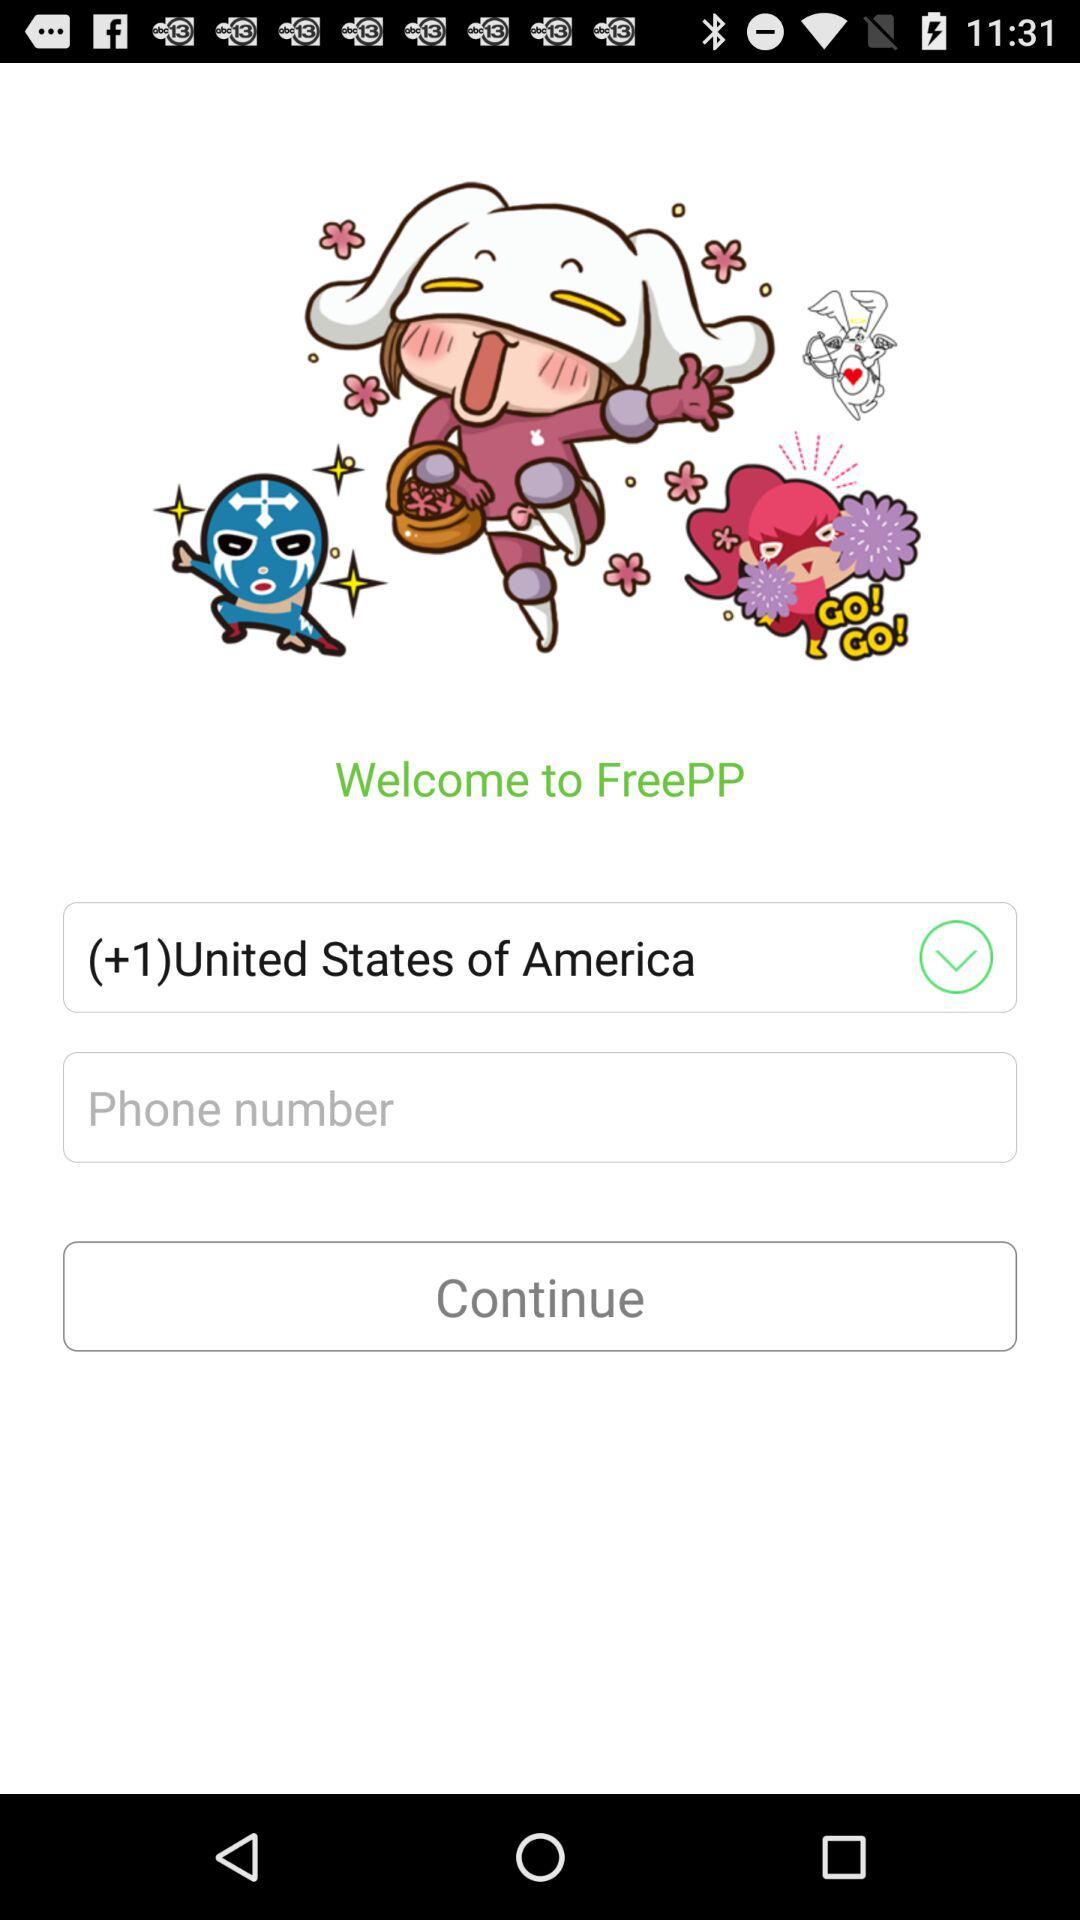Which country is selected? The selected country is the United States of America. 